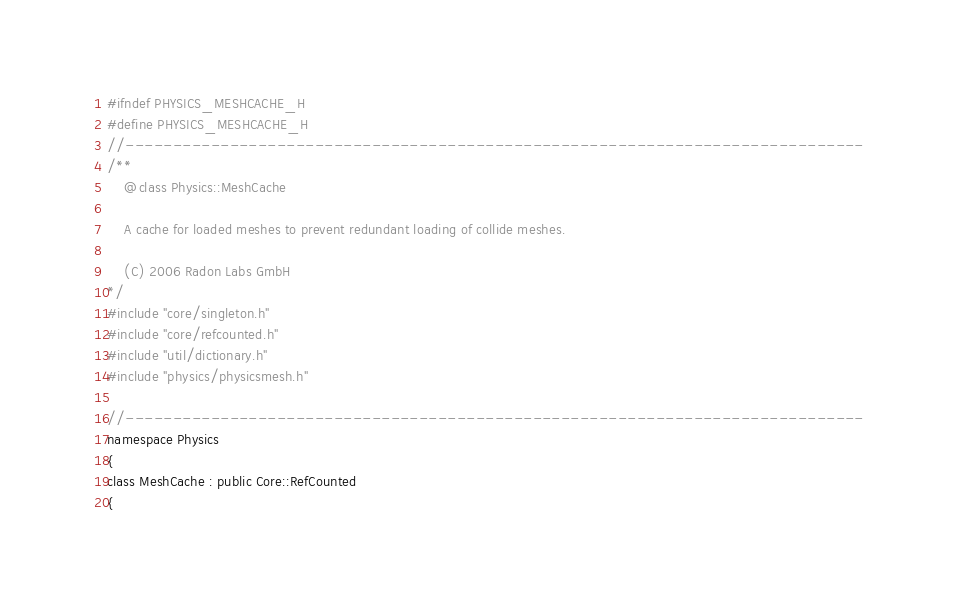<code> <loc_0><loc_0><loc_500><loc_500><_C_>#ifndef PHYSICS_MESHCACHE_H
#define PHYSICS_MESHCACHE_H
//------------------------------------------------------------------------------
/**
    @class Physics::MeshCache
    
    A cache for loaded meshes to prevent redundant loading of collide meshes.
    
    (C) 2006 Radon Labs GmbH
*/
#include "core/singleton.h"
#include "core/refcounted.h"
#include "util/dictionary.h"
#include "physics/physicsmesh.h"

//------------------------------------------------------------------------------
namespace Physics
{
class MeshCache : public Core::RefCounted
{</code> 